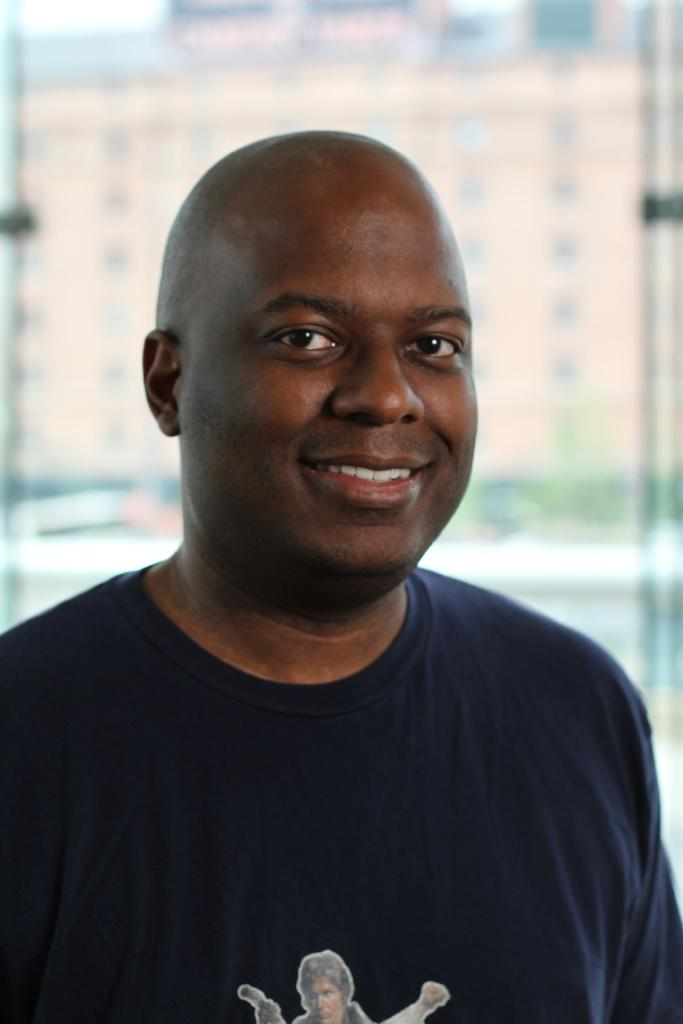Who is present in the image? There is a man in the image. What is the man's facial expression? The man is smiling. What can be seen in the background of the image? There is a building in the background of the image. How is the building depicted in the image? The building appears to be blurred. What measures has the man taken to push the building in the image? There is no indication in the image that the man is attempting to push the building, nor is there any evidence of him taking any measures to do so. 